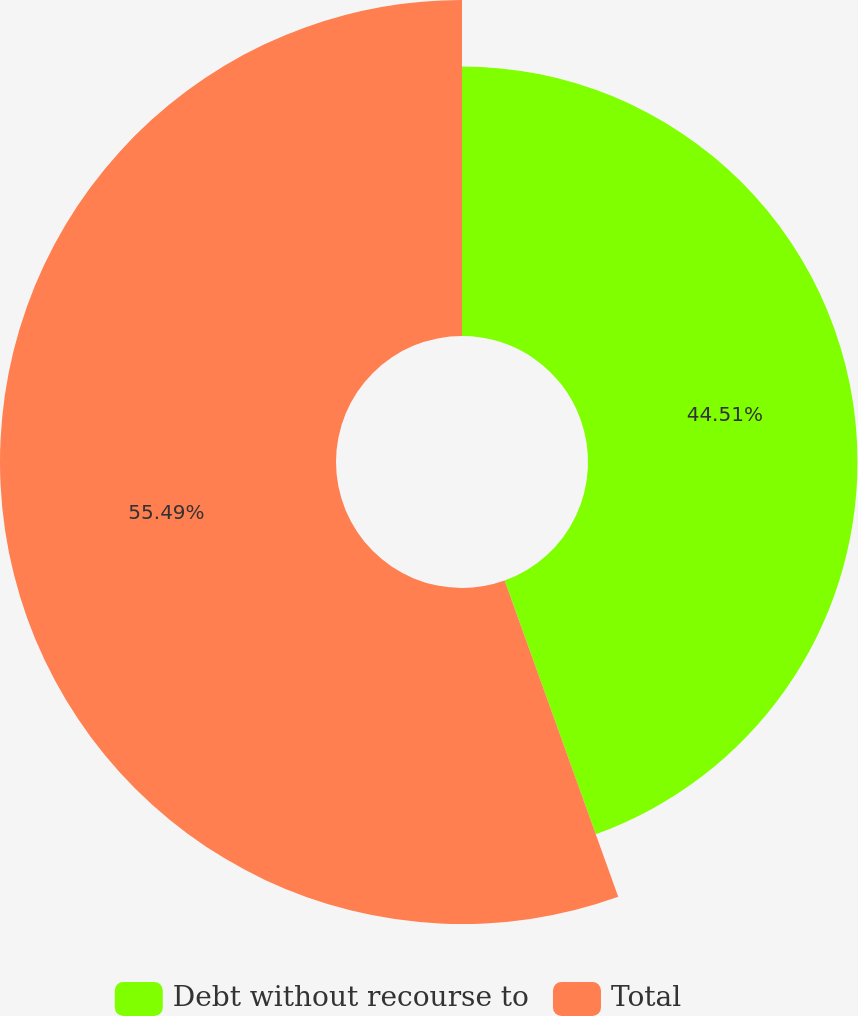<chart> <loc_0><loc_0><loc_500><loc_500><pie_chart><fcel>Debt without recourse to<fcel>Total<nl><fcel>44.51%<fcel>55.49%<nl></chart> 